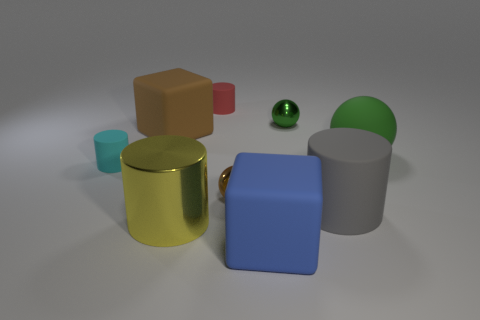How many other objects are the same size as the green matte ball?
Provide a short and direct response. 4. What is the size of the cylinder that is to the left of the big gray cylinder and in front of the tiny brown metal thing?
Your answer should be compact. Large. Do the large rubber sphere and the tiny ball that is behind the large brown object have the same color?
Ensure brevity in your answer.  Yes. Is there a small cyan rubber object of the same shape as the large metallic thing?
Ensure brevity in your answer.  Yes. How many things are big metal things or cyan rubber cylinders that are left of the big yellow object?
Provide a succinct answer. 2. What number of other things are there of the same material as the red object
Your answer should be compact. 5. How many things are small green shiny things or cyan rubber things?
Provide a short and direct response. 2. Is the number of big brown matte things that are right of the tiny cyan cylinder greater than the number of gray things that are on the left side of the tiny red matte cylinder?
Your response must be concise. Yes. There is a large matte cube left of the tiny red cylinder; is it the same color as the metal sphere that is in front of the brown matte thing?
Give a very brief answer. Yes. How big is the cylinder that is on the left side of the cube that is to the left of the small cylinder that is behind the tiny green sphere?
Your answer should be very brief. Small. 